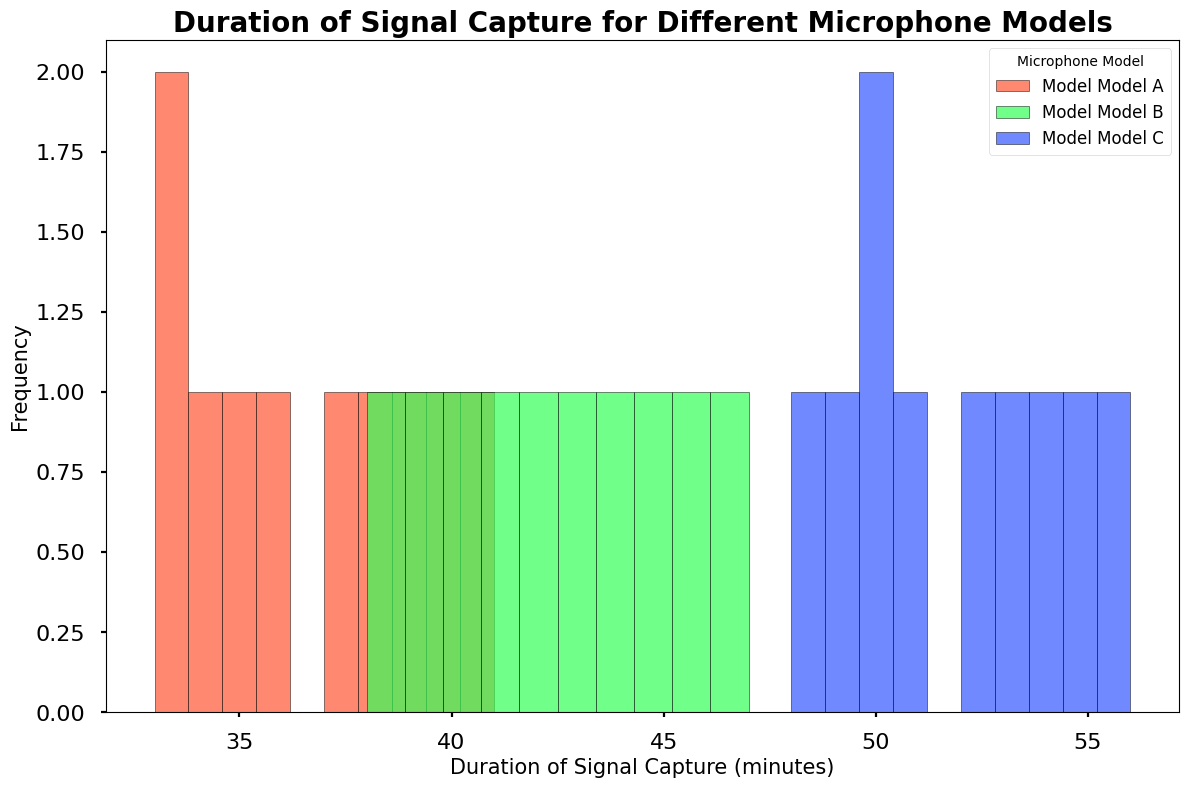What is the most frequent duration of signal capture for Model C? Observe the histogram for Model C, which is the one colored green. The bar with the highest frequency represents the most frequent duration.
Answer: 50-56 minutes Which microphone model has the longest signal capture duration? Find the histogram with the highest maximum value on the x-axis. Model C has signal capture durations extending up to 56 minutes.
Answer: Model C What is the difference between the longest captured durations for Model A and Model B? The longest duration for Model A is 41 minutes, and for Model B, it's 47 minutes. Subtract 41 from 47 to get the difference.
Answer: 6 minutes What is the range of the signal capture duration for Model A? The range is the difference between the maximum and minimum values. For Model A, the maximum duration is 41 minutes, and the minimum is 33 minutes. The range is 41 - 33.
Answer: 8 minutes Which model has the highest frequency at 40 minutes of duration? Observe the histograms and check which bar for 40 minutes has the greatest height. Model B has a higher frequency at 40 minutes than Model A and Model C (note, Model C does not capture at exactly 40 minutes).
Answer: Model B How does the frequency distribution of Model A compare to Model B in the 30-35 minutes range? Compare the heights of the bars in the 30-35 minutes range for Model A (red) and Model B (blue). Model A has higher bars in this range compared to Model B.
Answer: Model A has a higher frequency If you combine the longest signal capture durations of all three models, what would be the total? Sum the maximum durations for Model A (41 minutes), Model B (47 minutes), and Model C (56 minutes). 41 + 47 + 56 = 144.
Answer: 144 minutes Which model has the most varied (widest range) signal capture duration? Calculate the range for each model and compare. Model C ranges from 48 to 56 minutes (8 minutes), Model A from 33 to 41 minutes (8 minutes), and Model B from 38 to 47 minutes (9 minutes). Model C and Model A have equal highest ranges over Model B.
Answer: Model B What is the average duration of signal capture for Model C? Sum up the durations for Model C and divide by the number of data points. The sum is 50 + 52 + 54 + 56 + 51 + 50 + 49 + 55 + 53 + 48 = 518. There are 10 data points. 518 / 10 = 51.8 minutes.
Answer: 51.8 minutes Which microphone model generally captures data for a longer duration? Compare the overall spread of the histograms. Model C appears to capture data for generally longer durations compared to Model A and Model B.
Answer: Model C What is the median duration for Model B? List out the capture durations for Model B, sort them, and find the middle value. Sorted: 38, 39, 40, 41, 42, 43, 44, 45, 46, 47. The median is the average of 5th and 6th values (42, 43). (42 + 43) / 2 = 42.5.
Answer: 42.5 minutes 